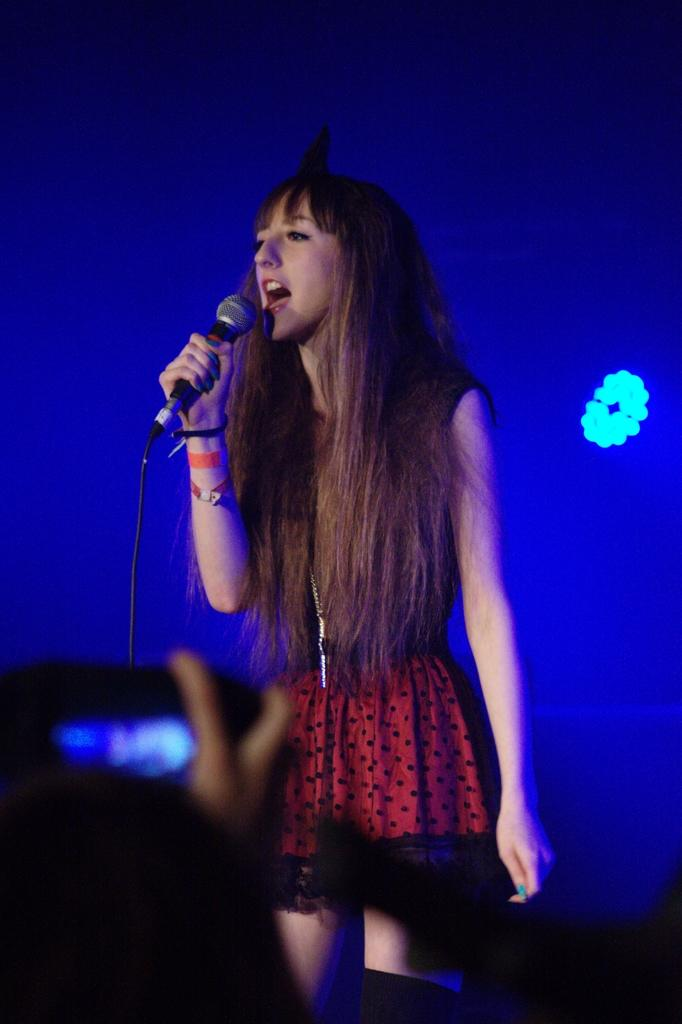What is the person in the image doing? The person is standing and holding a microphone. What object can be seen in the person's hand? The person is holding a microphone. What can be seen in the image that provides illumination? There is a light in the image. What color is the background of the image? The background of the image is blue. What type of notebook is the expert holding in the image? There is no expert or notebook present in the image. 